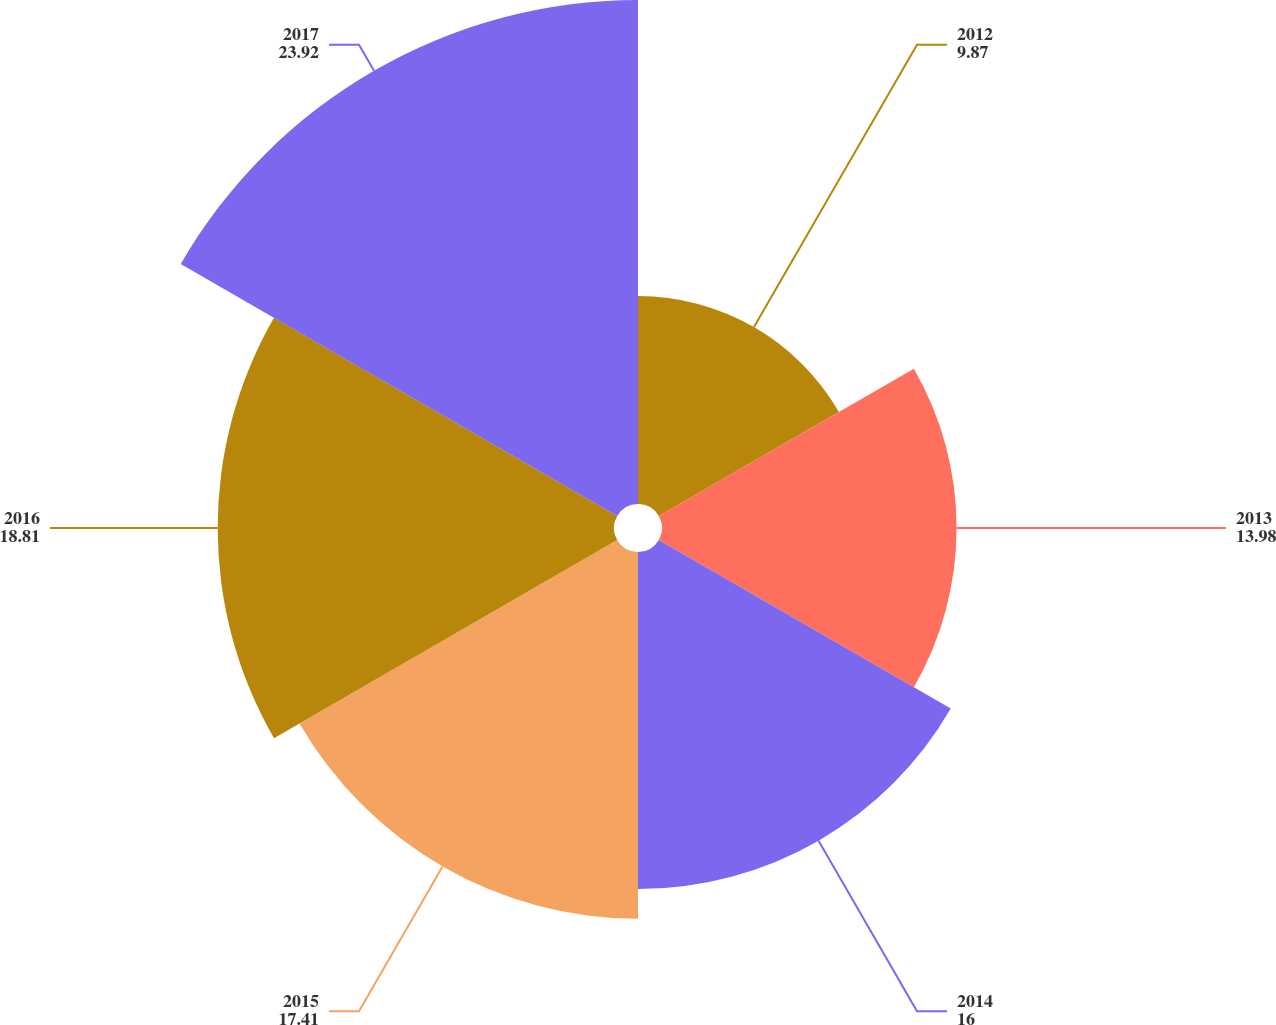Convert chart. <chart><loc_0><loc_0><loc_500><loc_500><pie_chart><fcel>2012<fcel>2013<fcel>2014<fcel>2015<fcel>2016<fcel>2017<nl><fcel>9.87%<fcel>13.98%<fcel>16.0%<fcel>17.41%<fcel>18.81%<fcel>23.92%<nl></chart> 